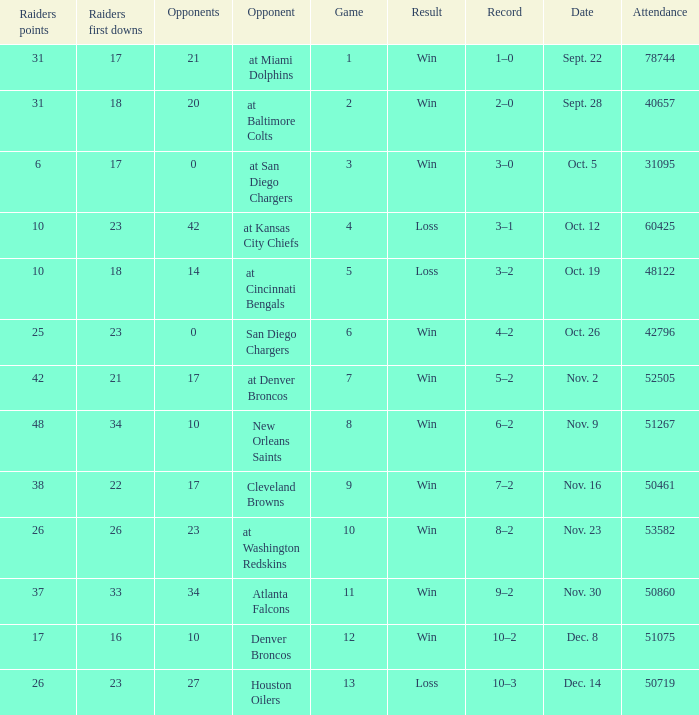What's the record in the game played against 42? 3–1. 